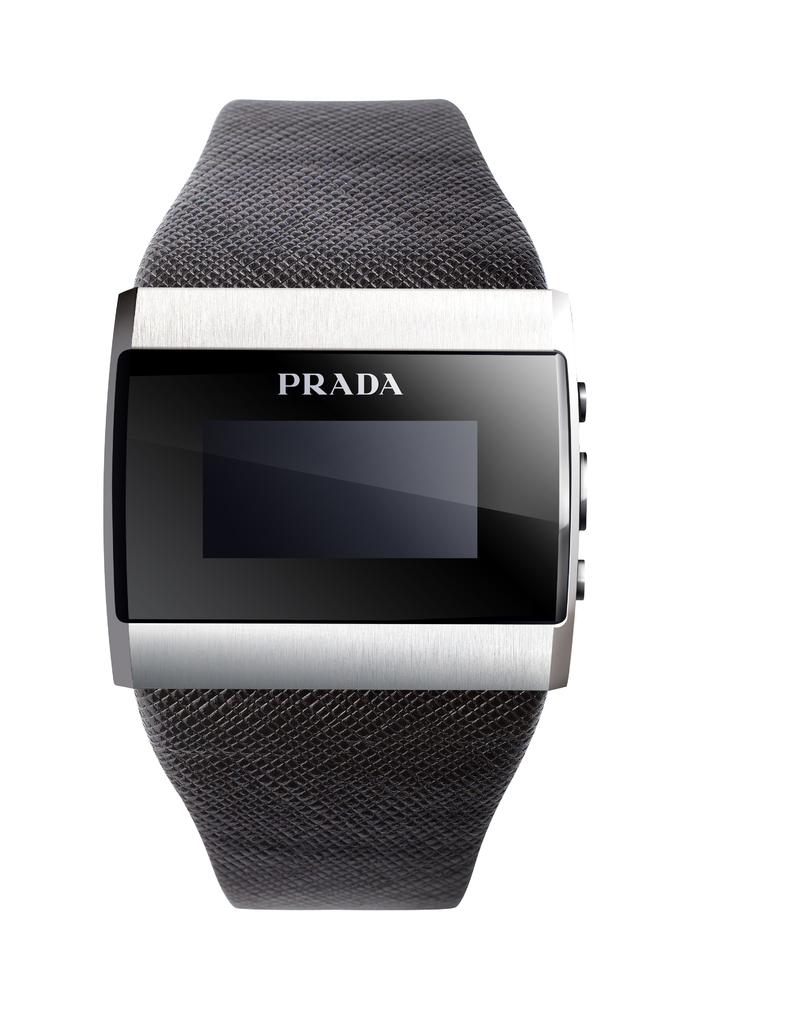<image>
Describe the image concisely. A Prada watch has a black band and three buttons on the right side. 